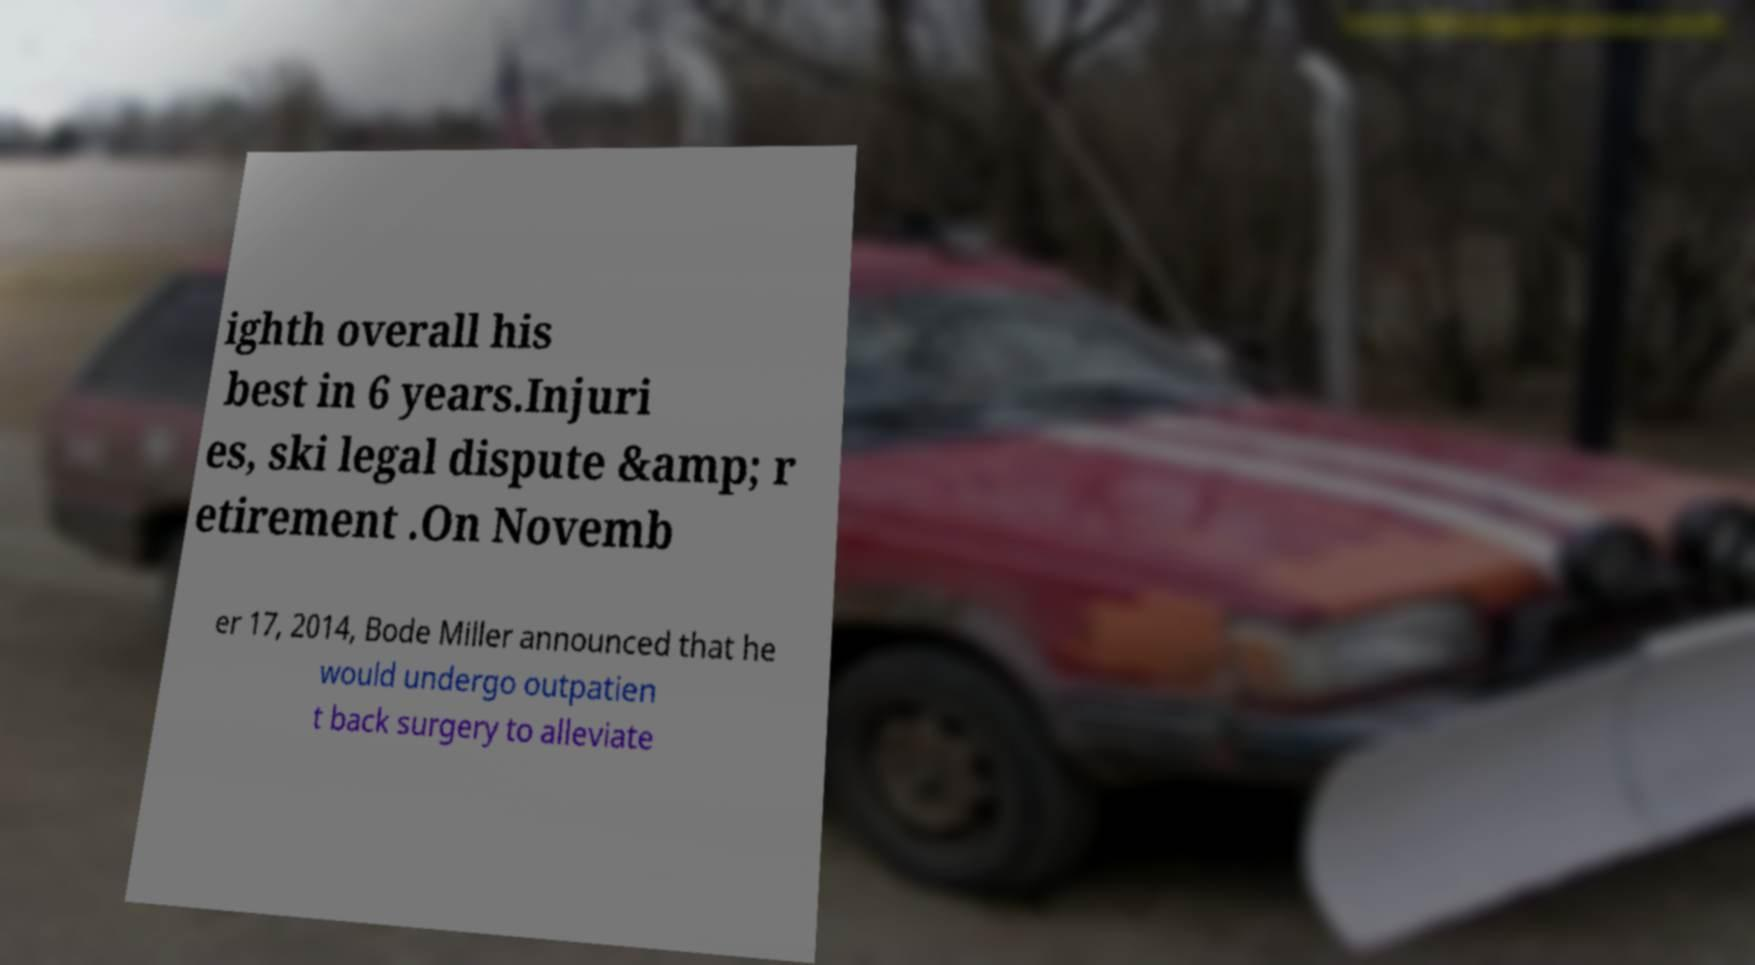For documentation purposes, I need the text within this image transcribed. Could you provide that? ighth overall his best in 6 years.Injuri es, ski legal dispute &amp; r etirement .On Novemb er 17, 2014, Bode Miller announced that he would undergo outpatien t back surgery to alleviate 